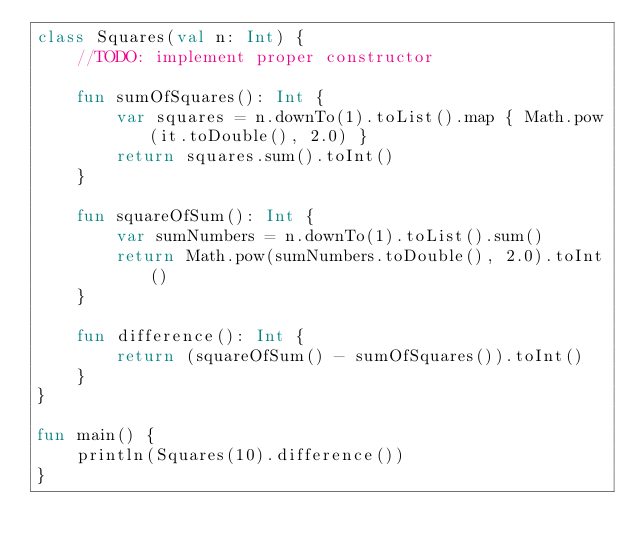Convert code to text. <code><loc_0><loc_0><loc_500><loc_500><_Kotlin_>class Squares(val n: Int) {
    //TODO: implement proper constructor

    fun sumOfSquares(): Int {
        var squares = n.downTo(1).toList().map { Math.pow(it.toDouble(), 2.0) }
        return squares.sum().toInt()
    }

    fun squareOfSum(): Int {
        var sumNumbers = n.downTo(1).toList().sum()
        return Math.pow(sumNumbers.toDouble(), 2.0).toInt()
    }

    fun difference(): Int {
        return (squareOfSum() - sumOfSquares()).toInt()
    }
}

fun main() {
    println(Squares(10).difference())
}</code> 